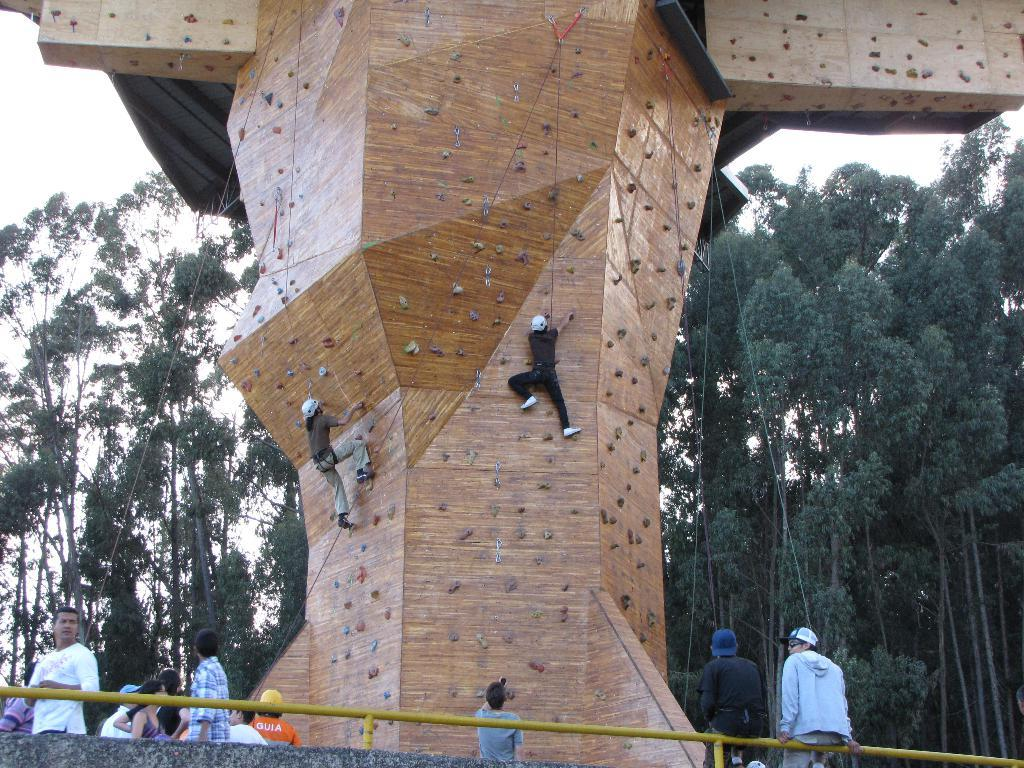How many people are in the image? There are multiple persons in the image. What are the different positions of the persons in the image? Some of the persons are standing, some are sitting, and some are climbing. What can be seen in the background of the image? There are trees in the background of the image. What type of pen is the horse holding in the image? There is no horse or pen present in the image. What town can be seen in the background of the image? The image does not show a town in the background; it only features trees. 